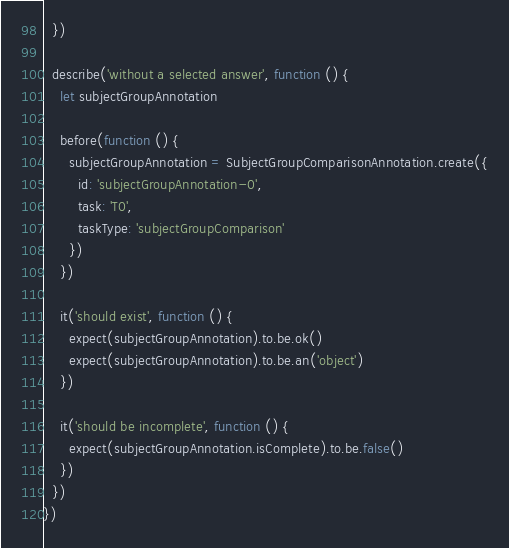Convert code to text. <code><loc_0><loc_0><loc_500><loc_500><_JavaScript_>  })

  describe('without a selected answer', function () {
    let subjectGroupAnnotation

    before(function () {
      subjectGroupAnnotation = SubjectGroupComparisonAnnotation.create({
        id: 'subjectGroupAnnotation-0',
        task: 'T0',
        taskType: 'subjectGroupComparison'
      })
    })

    it('should exist', function () {
      expect(subjectGroupAnnotation).to.be.ok()
      expect(subjectGroupAnnotation).to.be.an('object')
    })

    it('should be incomplete', function () {
      expect(subjectGroupAnnotation.isComplete).to.be.false()
    })
  })
})
</code> 